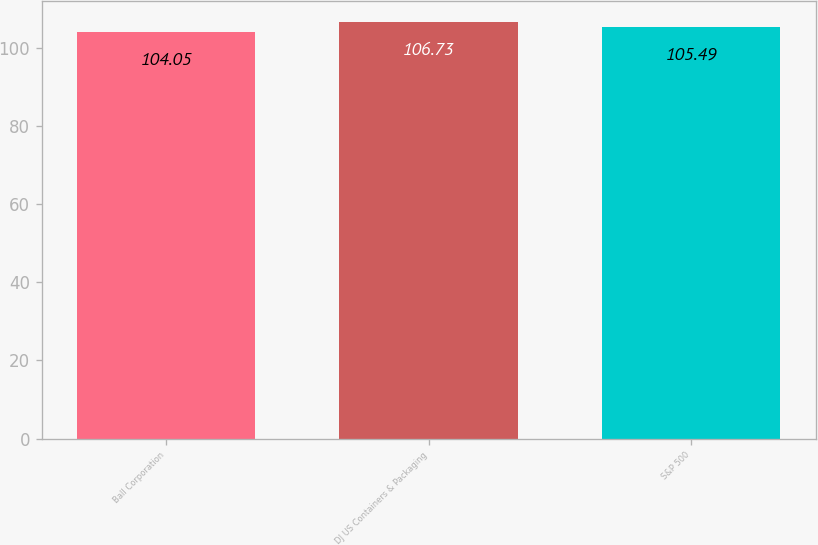Convert chart to OTSL. <chart><loc_0><loc_0><loc_500><loc_500><bar_chart><fcel>Ball Corporation<fcel>DJ US Containers & Packaging<fcel>S&P 500<nl><fcel>104.05<fcel>106.73<fcel>105.49<nl></chart> 